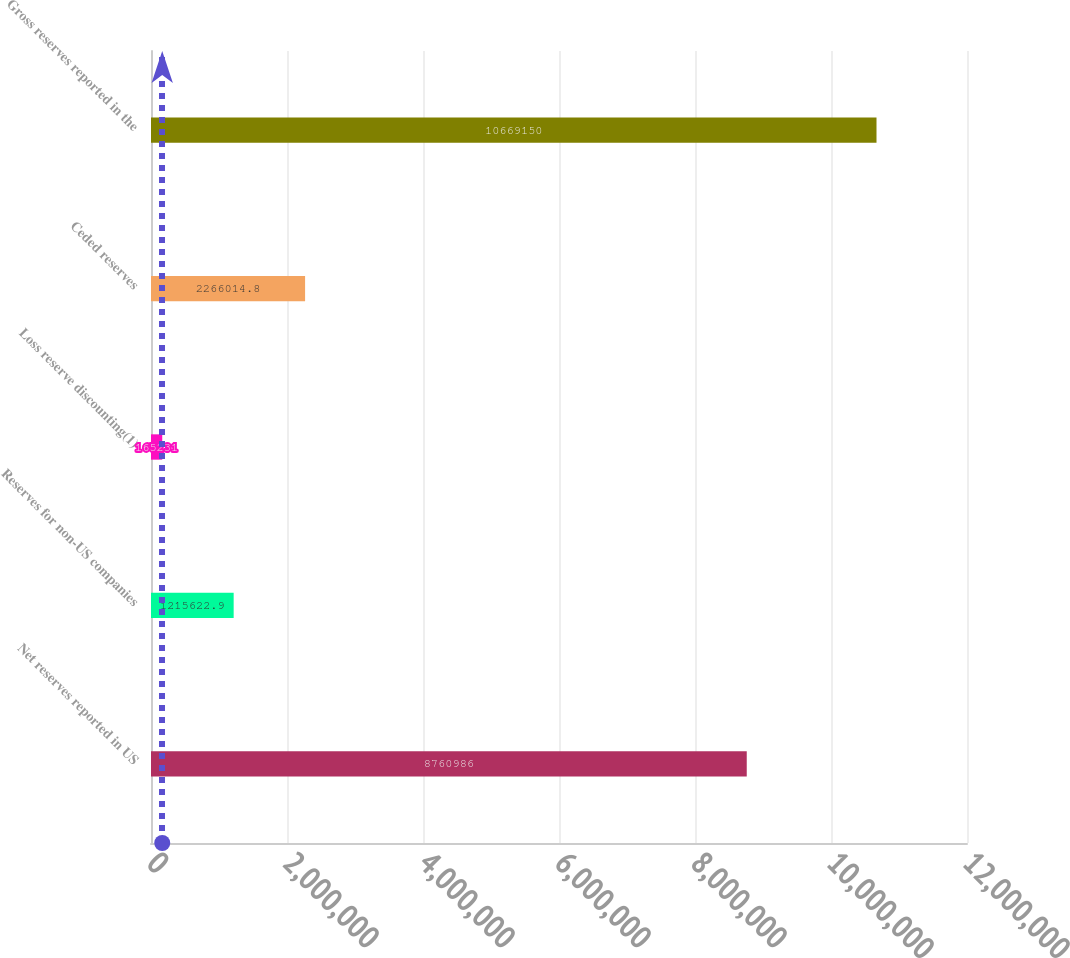Convert chart. <chart><loc_0><loc_0><loc_500><loc_500><bar_chart><fcel>Net reserves reported in US<fcel>Reserves for non-US companies<fcel>Loss reserve discounting(1)<fcel>Ceded reserves<fcel>Gross reserves reported in the<nl><fcel>8.76099e+06<fcel>1.21562e+06<fcel>165231<fcel>2.26601e+06<fcel>1.06692e+07<nl></chart> 